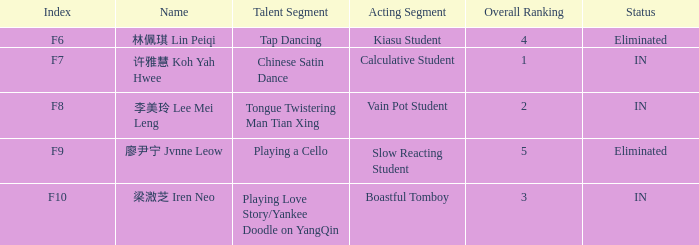What's the complete count of discarded positions in 廖尹宁 jvnne leow's events? 1.0. 